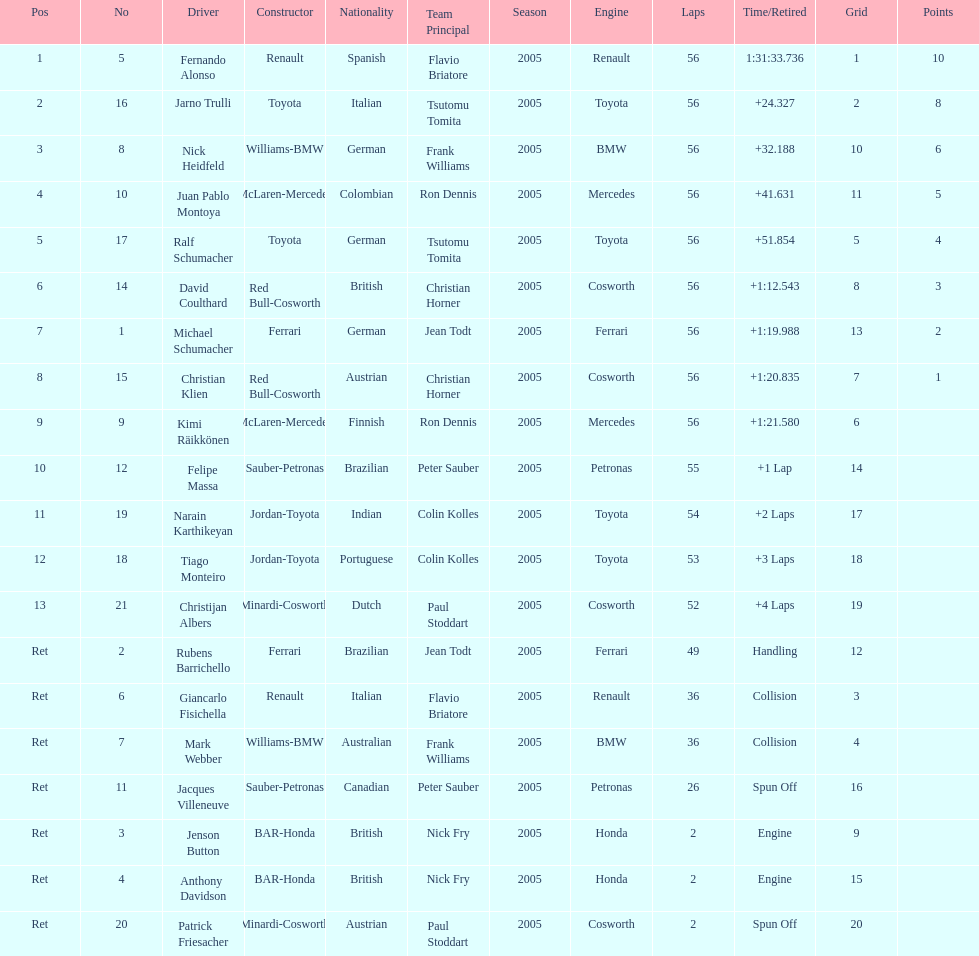How long did it take for heidfeld to finish? 1:31:65.924. Give me the full table as a dictionary. {'header': ['Pos', 'No', 'Driver', 'Constructor', 'Nationality', 'Team Principal', 'Season', 'Engine', 'Laps', 'Time/Retired', 'Grid', 'Points'], 'rows': [['1', '5', 'Fernando Alonso', 'Renault', 'Spanish', 'Flavio Briatore', '2005', 'Renault', '56', '1:31:33.736', '1', '10'], ['2', '16', 'Jarno Trulli', 'Toyota', 'Italian', 'Tsutomu Tomita', '2005', 'Toyota', '56', '+24.327', '2', '8'], ['3', '8', 'Nick Heidfeld', 'Williams-BMW', 'German', 'Frank Williams', '2005', 'BMW', '56', '+32.188', '10', '6'], ['4', '10', 'Juan Pablo Montoya', 'McLaren-Mercedes', 'Colombian', 'Ron Dennis', '2005', 'Mercedes', '56', '+41.631', '11', '5'], ['5', '17', 'Ralf Schumacher', 'Toyota', 'German', 'Tsutomu Tomita', '2005', 'Toyota', '56', '+51.854', '5', '4'], ['6', '14', 'David Coulthard', 'Red Bull-Cosworth', 'British', 'Christian Horner', '2005', 'Cosworth', '56', '+1:12.543', '8', '3'], ['7', '1', 'Michael Schumacher', 'Ferrari', 'German', 'Jean Todt', '2005', 'Ferrari', '56', '+1:19.988', '13', '2'], ['8', '15', 'Christian Klien', 'Red Bull-Cosworth', 'Austrian', 'Christian Horner', '2005', 'Cosworth', '56', '+1:20.835', '7', '1'], ['9', '9', 'Kimi Räikkönen', 'McLaren-Mercedes', 'Finnish', 'Ron Dennis', '2005', 'Mercedes', '56', '+1:21.580', '6', ''], ['10', '12', 'Felipe Massa', 'Sauber-Petronas', 'Brazilian', 'Peter Sauber', '2005', 'Petronas', '55', '+1 Lap', '14', ''], ['11', '19', 'Narain Karthikeyan', 'Jordan-Toyota', 'Indian', 'Colin Kolles', '2005', 'Toyota', '54', '+2 Laps', '17', ''], ['12', '18', 'Tiago Monteiro', 'Jordan-Toyota', 'Portuguese', 'Colin Kolles', '2005', 'Toyota', '53', '+3 Laps', '18', ''], ['13', '21', 'Christijan Albers', 'Minardi-Cosworth', 'Dutch', 'Paul Stoddart', '2005', 'Cosworth', '52', '+4 Laps', '19', ''], ['Ret', '2', 'Rubens Barrichello', 'Ferrari', 'Brazilian', 'Jean Todt', '2005', 'Ferrari', '49', 'Handling', '12', ''], ['Ret', '6', 'Giancarlo Fisichella', 'Renault', 'Italian', 'Flavio Briatore', '2005', 'Renault', '36', 'Collision', '3', ''], ['Ret', '7', 'Mark Webber', 'Williams-BMW', 'Australian', 'Frank Williams', '2005', 'BMW', '36', 'Collision', '4', ''], ['Ret', '11', 'Jacques Villeneuve', 'Sauber-Petronas', 'Canadian', 'Peter Sauber', '2005', 'Petronas', '26', 'Spun Off', '16', ''], ['Ret', '3', 'Jenson Button', 'BAR-Honda', 'British', 'Nick Fry', '2005', 'Honda', '2', 'Engine', '9', ''], ['Ret', '4', 'Anthony Davidson', 'BAR-Honda', 'British', 'Nick Fry', '2005', 'Honda', '2', 'Engine', '15', ''], ['Ret', '20', 'Patrick Friesacher', 'Minardi-Cosworth', 'Austrian', 'Paul Stoddart', '2005', 'Cosworth', '2', 'Spun Off', '20', '']]} 